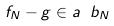Convert formula to latex. <formula><loc_0><loc_0><loc_500><loc_500>f _ { N } - g \in a \ b _ { N }</formula> 